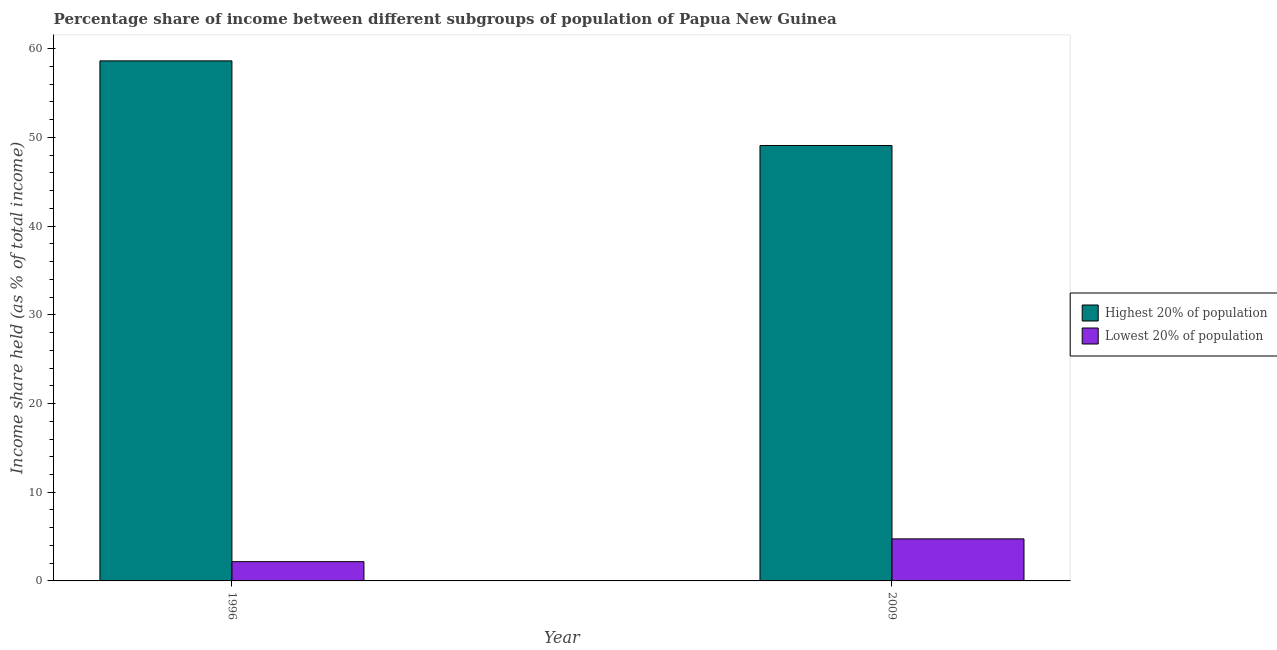How many groups of bars are there?
Your answer should be compact. 2. Are the number of bars per tick equal to the number of legend labels?
Your answer should be very brief. Yes. How many bars are there on the 1st tick from the left?
Provide a short and direct response. 2. What is the label of the 1st group of bars from the left?
Make the answer very short. 1996. In how many cases, is the number of bars for a given year not equal to the number of legend labels?
Ensure brevity in your answer.  0. What is the income share held by lowest 20% of the population in 1996?
Your answer should be very brief. 2.17. Across all years, what is the maximum income share held by highest 20% of the population?
Provide a short and direct response. 58.63. Across all years, what is the minimum income share held by highest 20% of the population?
Keep it short and to the point. 49.09. In which year was the income share held by highest 20% of the population minimum?
Ensure brevity in your answer.  2009. What is the total income share held by highest 20% of the population in the graph?
Provide a short and direct response. 107.72. What is the difference between the income share held by highest 20% of the population in 1996 and that in 2009?
Your response must be concise. 9.54. What is the difference between the income share held by lowest 20% of the population in 2009 and the income share held by highest 20% of the population in 1996?
Your response must be concise. 2.57. What is the average income share held by lowest 20% of the population per year?
Your answer should be compact. 3.46. What is the ratio of the income share held by highest 20% of the population in 1996 to that in 2009?
Make the answer very short. 1.19. Is the income share held by lowest 20% of the population in 1996 less than that in 2009?
Keep it short and to the point. Yes. What does the 1st bar from the left in 2009 represents?
Your response must be concise. Highest 20% of population. What does the 1st bar from the right in 2009 represents?
Offer a terse response. Lowest 20% of population. Are the values on the major ticks of Y-axis written in scientific E-notation?
Offer a terse response. No. How many legend labels are there?
Provide a succinct answer. 2. How are the legend labels stacked?
Make the answer very short. Vertical. What is the title of the graph?
Offer a terse response. Percentage share of income between different subgroups of population of Papua New Guinea. Does "Quality of trade" appear as one of the legend labels in the graph?
Provide a short and direct response. No. What is the label or title of the Y-axis?
Keep it short and to the point. Income share held (as % of total income). What is the Income share held (as % of total income) in Highest 20% of population in 1996?
Ensure brevity in your answer.  58.63. What is the Income share held (as % of total income) in Lowest 20% of population in 1996?
Provide a short and direct response. 2.17. What is the Income share held (as % of total income) of Highest 20% of population in 2009?
Provide a succinct answer. 49.09. What is the Income share held (as % of total income) of Lowest 20% of population in 2009?
Give a very brief answer. 4.74. Across all years, what is the maximum Income share held (as % of total income) in Highest 20% of population?
Offer a very short reply. 58.63. Across all years, what is the maximum Income share held (as % of total income) of Lowest 20% of population?
Provide a succinct answer. 4.74. Across all years, what is the minimum Income share held (as % of total income) in Highest 20% of population?
Provide a short and direct response. 49.09. Across all years, what is the minimum Income share held (as % of total income) in Lowest 20% of population?
Make the answer very short. 2.17. What is the total Income share held (as % of total income) of Highest 20% of population in the graph?
Offer a terse response. 107.72. What is the total Income share held (as % of total income) in Lowest 20% of population in the graph?
Your answer should be compact. 6.91. What is the difference between the Income share held (as % of total income) of Highest 20% of population in 1996 and that in 2009?
Keep it short and to the point. 9.54. What is the difference between the Income share held (as % of total income) of Lowest 20% of population in 1996 and that in 2009?
Ensure brevity in your answer.  -2.57. What is the difference between the Income share held (as % of total income) of Highest 20% of population in 1996 and the Income share held (as % of total income) of Lowest 20% of population in 2009?
Provide a short and direct response. 53.89. What is the average Income share held (as % of total income) in Highest 20% of population per year?
Your answer should be compact. 53.86. What is the average Income share held (as % of total income) in Lowest 20% of population per year?
Your answer should be very brief. 3.46. In the year 1996, what is the difference between the Income share held (as % of total income) in Highest 20% of population and Income share held (as % of total income) in Lowest 20% of population?
Offer a very short reply. 56.46. In the year 2009, what is the difference between the Income share held (as % of total income) in Highest 20% of population and Income share held (as % of total income) in Lowest 20% of population?
Ensure brevity in your answer.  44.35. What is the ratio of the Income share held (as % of total income) of Highest 20% of population in 1996 to that in 2009?
Your answer should be very brief. 1.19. What is the ratio of the Income share held (as % of total income) of Lowest 20% of population in 1996 to that in 2009?
Give a very brief answer. 0.46. What is the difference between the highest and the second highest Income share held (as % of total income) of Highest 20% of population?
Give a very brief answer. 9.54. What is the difference between the highest and the second highest Income share held (as % of total income) in Lowest 20% of population?
Give a very brief answer. 2.57. What is the difference between the highest and the lowest Income share held (as % of total income) of Highest 20% of population?
Provide a succinct answer. 9.54. What is the difference between the highest and the lowest Income share held (as % of total income) of Lowest 20% of population?
Make the answer very short. 2.57. 